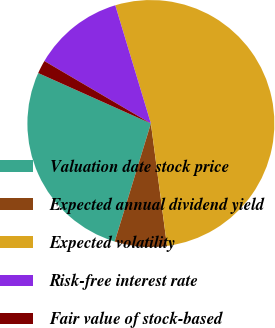Convert chart. <chart><loc_0><loc_0><loc_500><loc_500><pie_chart><fcel>Valuation date stock price<fcel>Expected annual dividend yield<fcel>Expected volatility<fcel>Risk-free interest rate<fcel>Fair value of stock-based<nl><fcel>26.97%<fcel>6.82%<fcel>52.57%<fcel>11.9%<fcel>1.74%<nl></chart> 